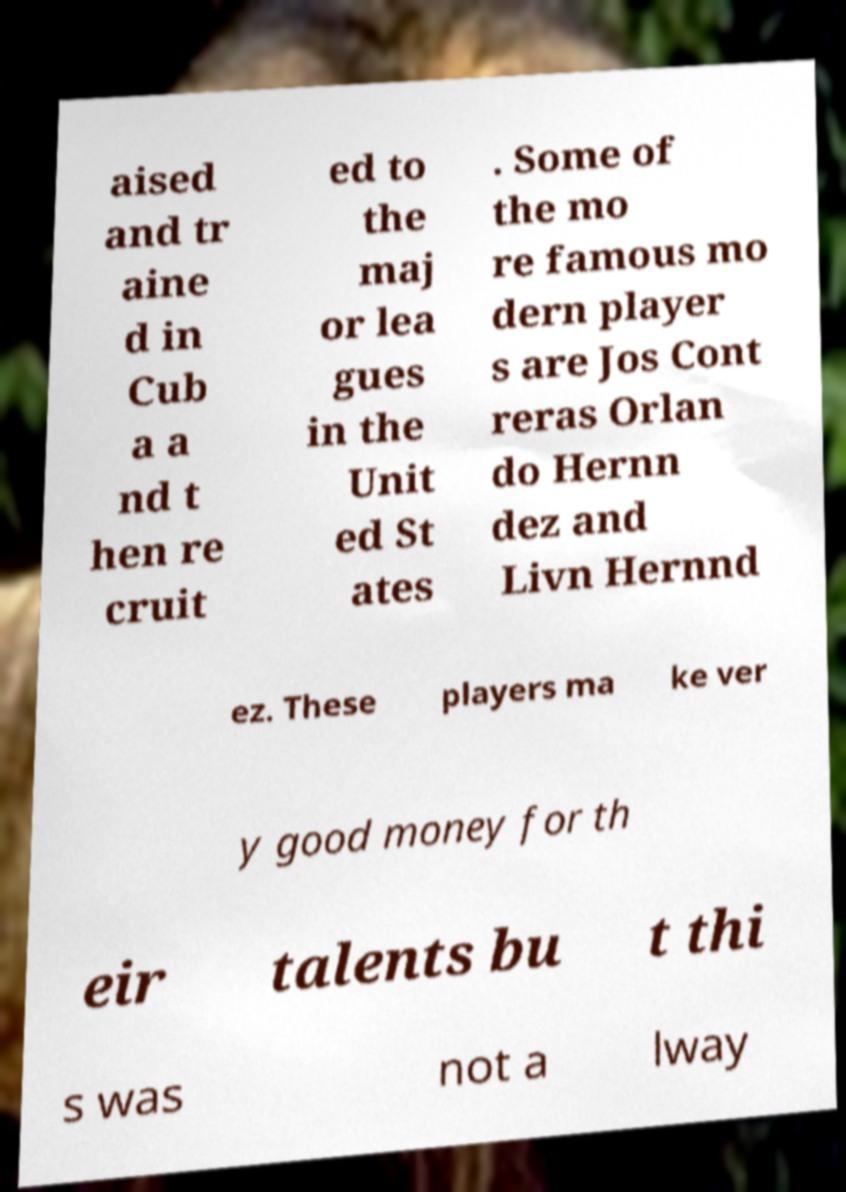I need the written content from this picture converted into text. Can you do that? aised and tr aine d in Cub a a nd t hen re cruit ed to the maj or lea gues in the Unit ed St ates . Some of the mo re famous mo dern player s are Jos Cont reras Orlan do Hernn dez and Livn Hernnd ez. These players ma ke ver y good money for th eir talents bu t thi s was not a lway 